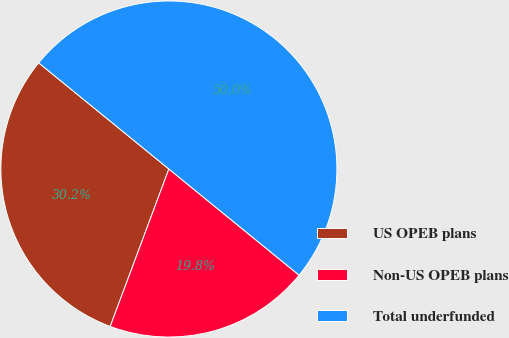Convert chart. <chart><loc_0><loc_0><loc_500><loc_500><pie_chart><fcel>US OPEB plans<fcel>Non-US OPEB plans<fcel>Total underfunded<nl><fcel>30.21%<fcel>19.79%<fcel>50.0%<nl></chart> 